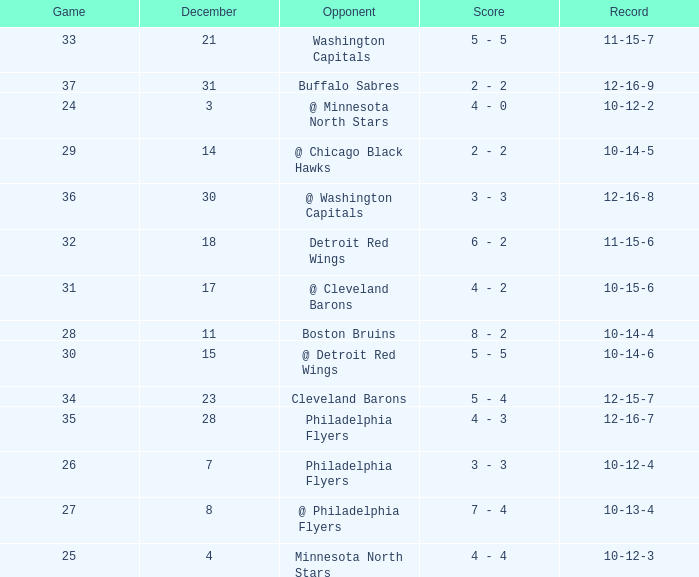What is Record, when Game is "24"? 10-12-2. 